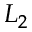Convert formula to latex. <formula><loc_0><loc_0><loc_500><loc_500>L _ { 2 }</formula> 